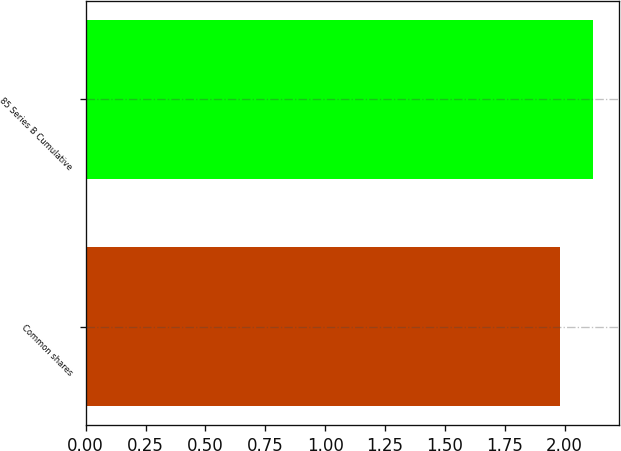Convert chart. <chart><loc_0><loc_0><loc_500><loc_500><bar_chart><fcel>Common shares<fcel>85 Series B Cumulative<nl><fcel>1.98<fcel>2.12<nl></chart> 